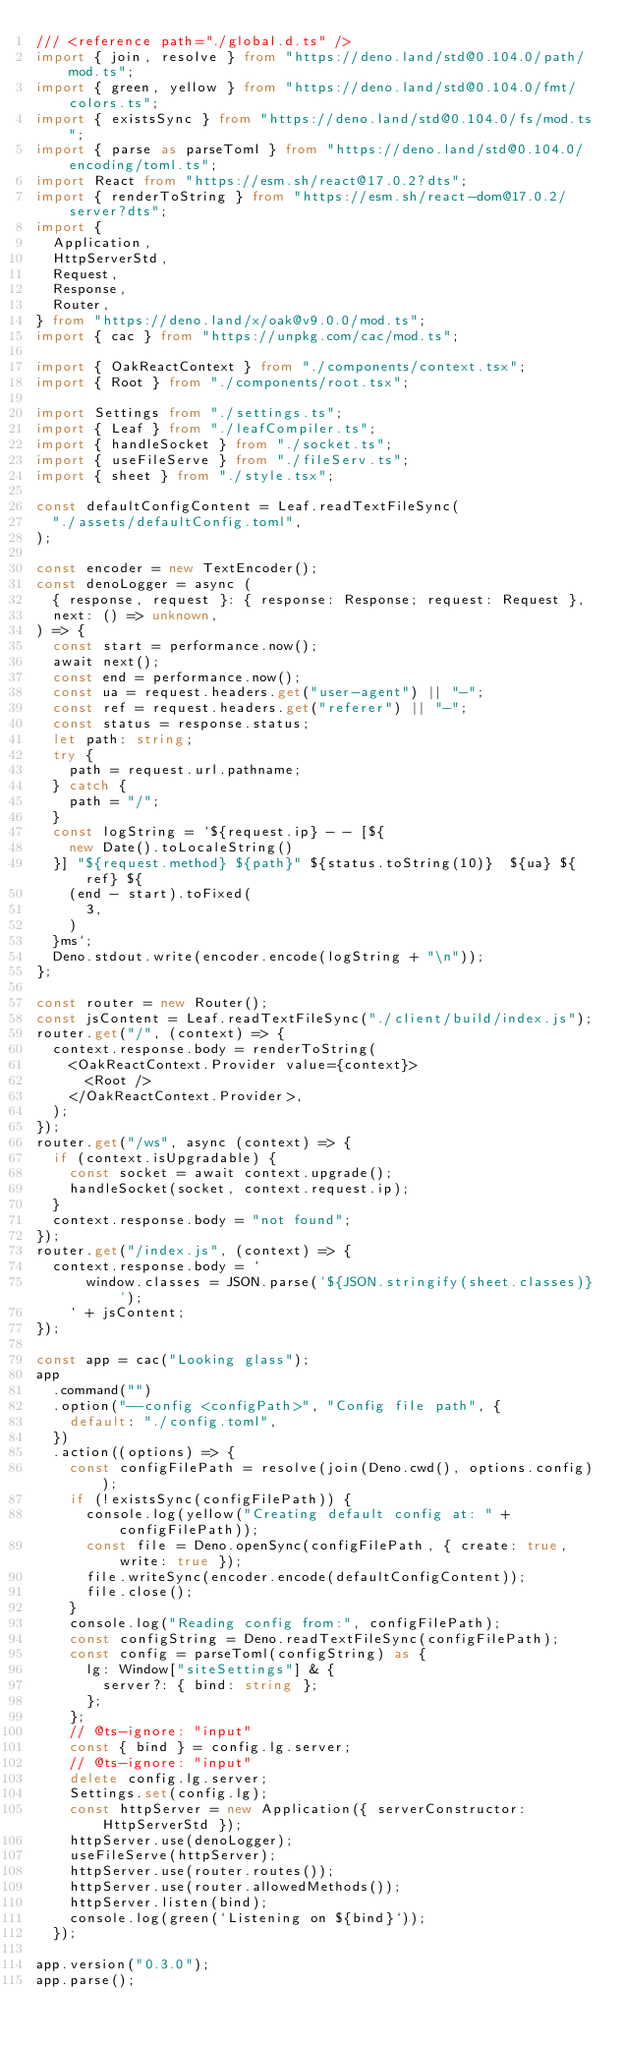<code> <loc_0><loc_0><loc_500><loc_500><_TypeScript_>/// <reference path="./global.d.ts" />
import { join, resolve } from "https://deno.land/std@0.104.0/path/mod.ts";
import { green, yellow } from "https://deno.land/std@0.104.0/fmt/colors.ts";
import { existsSync } from "https://deno.land/std@0.104.0/fs/mod.ts";
import { parse as parseToml } from "https://deno.land/std@0.104.0/encoding/toml.ts";
import React from "https://esm.sh/react@17.0.2?dts";
import { renderToString } from "https://esm.sh/react-dom@17.0.2/server?dts";
import {
  Application,
  HttpServerStd,
  Request,
  Response,
  Router,
} from "https://deno.land/x/oak@v9.0.0/mod.ts";
import { cac } from "https://unpkg.com/cac/mod.ts";

import { OakReactContext } from "./components/context.tsx";
import { Root } from "./components/root.tsx";

import Settings from "./settings.ts";
import { Leaf } from "./leafCompiler.ts";
import { handleSocket } from "./socket.ts";
import { useFileServe } from "./fileServ.ts";
import { sheet } from "./style.tsx";

const defaultConfigContent = Leaf.readTextFileSync(
  "./assets/defaultConfig.toml",
);

const encoder = new TextEncoder();
const denoLogger = async (
  { response, request }: { response: Response; request: Request },
  next: () => unknown,
) => {
  const start = performance.now();
  await next();
  const end = performance.now();
  const ua = request.headers.get("user-agent") || "-";
  const ref = request.headers.get("referer") || "-";
  const status = response.status;
  let path: string;
  try {
    path = request.url.pathname;
  } catch {
    path = "/";
  }
  const logString = `${request.ip} - - [${
    new Date().toLocaleString()
  }] "${request.method} ${path}" ${status.toString(10)}  ${ua} ${ref} ${
    (end - start).toFixed(
      3,
    )
  }ms`;
  Deno.stdout.write(encoder.encode(logString + "\n"));
};

const router = new Router();
const jsContent = Leaf.readTextFileSync("./client/build/index.js");
router.get("/", (context) => {
  context.response.body = renderToString(
    <OakReactContext.Provider value={context}>
      <Root />
    </OakReactContext.Provider>,
  );
});
router.get("/ws", async (context) => {
  if (context.isUpgradable) {
    const socket = await context.upgrade();
    handleSocket(socket, context.request.ip);
  }
  context.response.body = "not found";
});
router.get("/index.js", (context) => {
  context.response.body = `
      window.classes = JSON.parse('${JSON.stringify(sheet.classes)}');
    ` + jsContent;
});

const app = cac("Looking glass");
app
  .command("")
  .option("--config <configPath>", "Config file path", {
    default: "./config.toml",
  })
  .action((options) => {
    const configFilePath = resolve(join(Deno.cwd(), options.config));
    if (!existsSync(configFilePath)) {
      console.log(yellow("Creating default config at: " + configFilePath));
      const file = Deno.openSync(configFilePath, { create: true, write: true });
      file.writeSync(encoder.encode(defaultConfigContent));
      file.close();
    }
    console.log("Reading config from:", configFilePath);
    const configString = Deno.readTextFileSync(configFilePath);
    const config = parseToml(configString) as {
      lg: Window["siteSettings"] & {
        server?: { bind: string };
      };
    };
    // @ts-ignore: "input"
    const { bind } = config.lg.server;
    // @ts-ignore: "input"
    delete config.lg.server;
    Settings.set(config.lg);
    const httpServer = new Application({ serverConstructor: HttpServerStd });
    httpServer.use(denoLogger);
    useFileServe(httpServer);
    httpServer.use(router.routes());
    httpServer.use(router.allowedMethods());
    httpServer.listen(bind);
    console.log(green(`Listening on ${bind}`));
  });

app.version("0.3.0");
app.parse();
</code> 